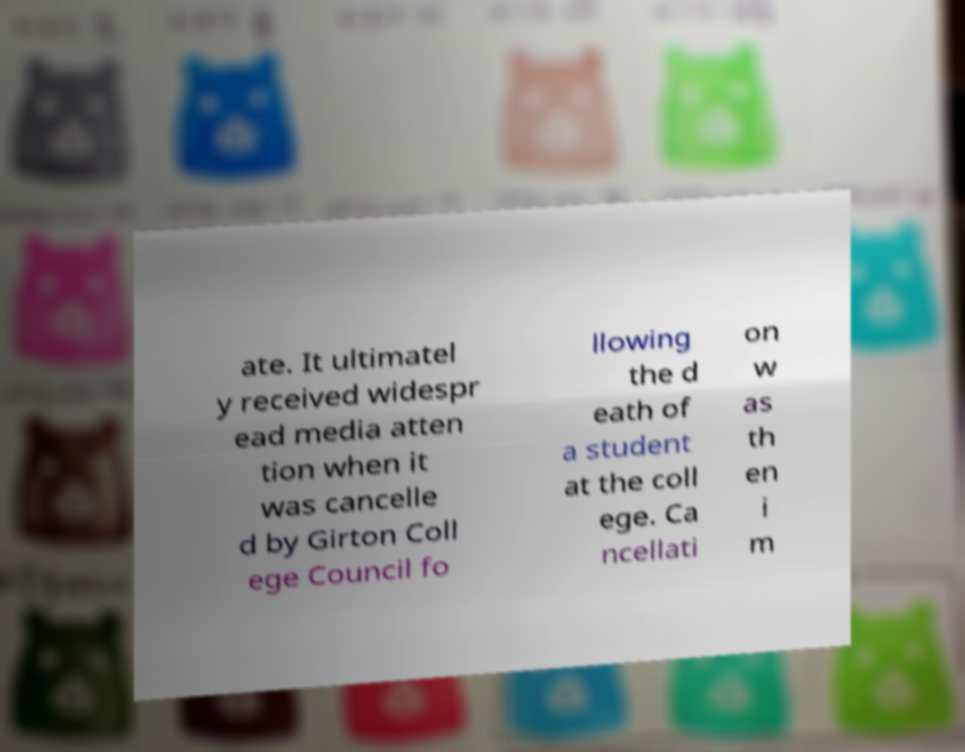Can you accurately transcribe the text from the provided image for me? ate. It ultimatel y received widespr ead media atten tion when it was cancelle d by Girton Coll ege Council fo llowing the d eath of a student at the coll ege. Ca ncellati on w as th en i m 